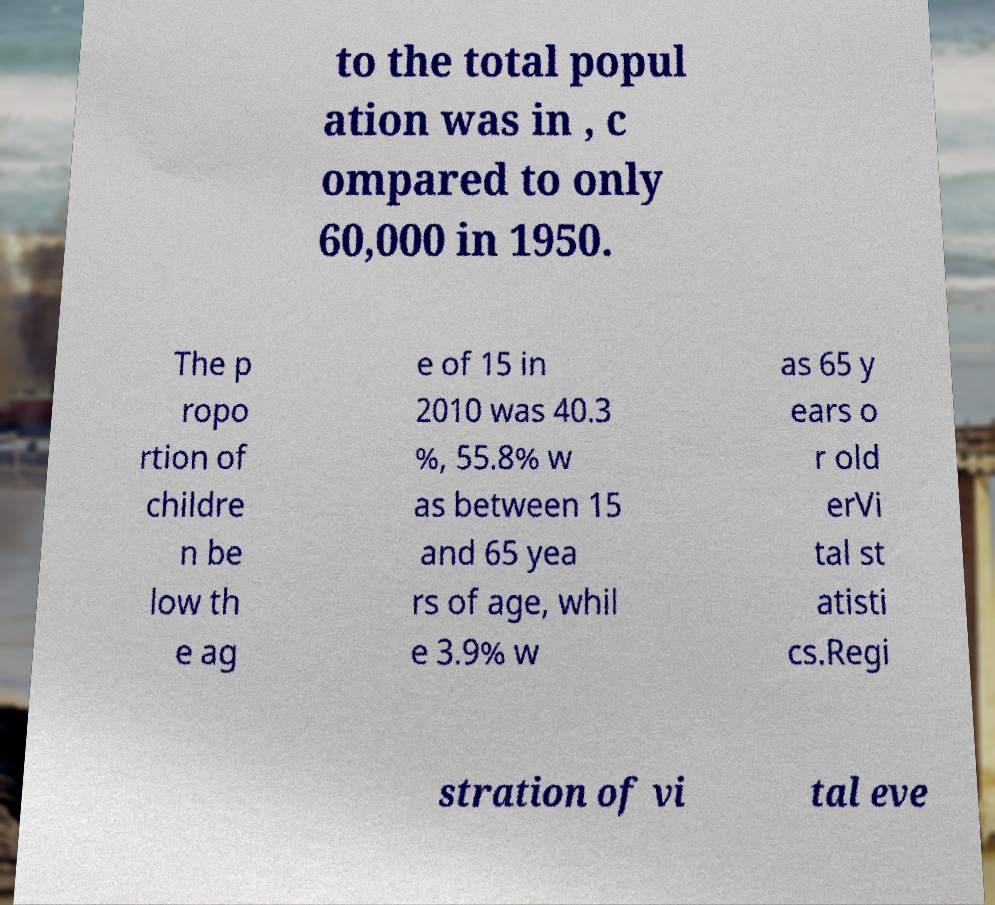Can you read and provide the text displayed in the image?This photo seems to have some interesting text. Can you extract and type it out for me? to the total popul ation was in , c ompared to only 60,000 in 1950. The p ropo rtion of childre n be low th e ag e of 15 in 2010 was 40.3 %, 55.8% w as between 15 and 65 yea rs of age, whil e 3.9% w as 65 y ears o r old erVi tal st atisti cs.Regi stration of vi tal eve 